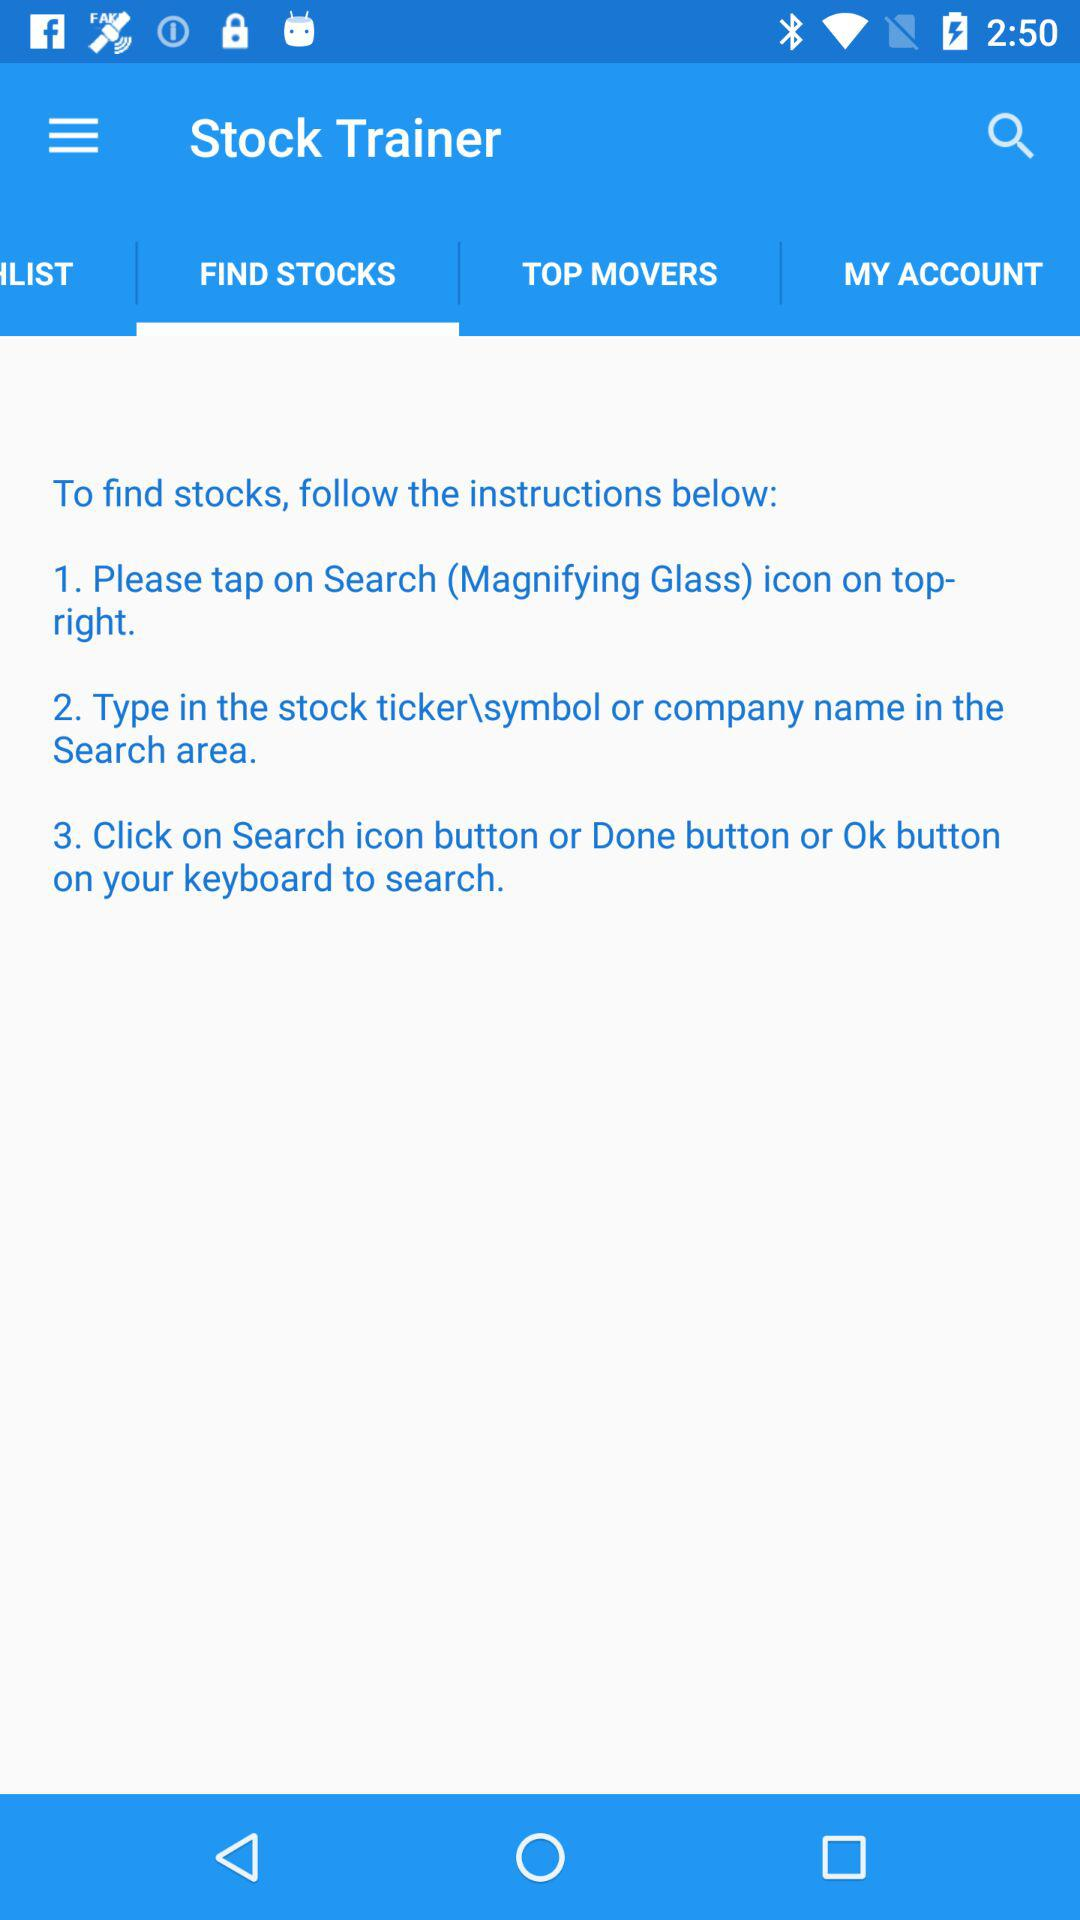What is the selected tab? The selected tab is "FIND STOCKS". 